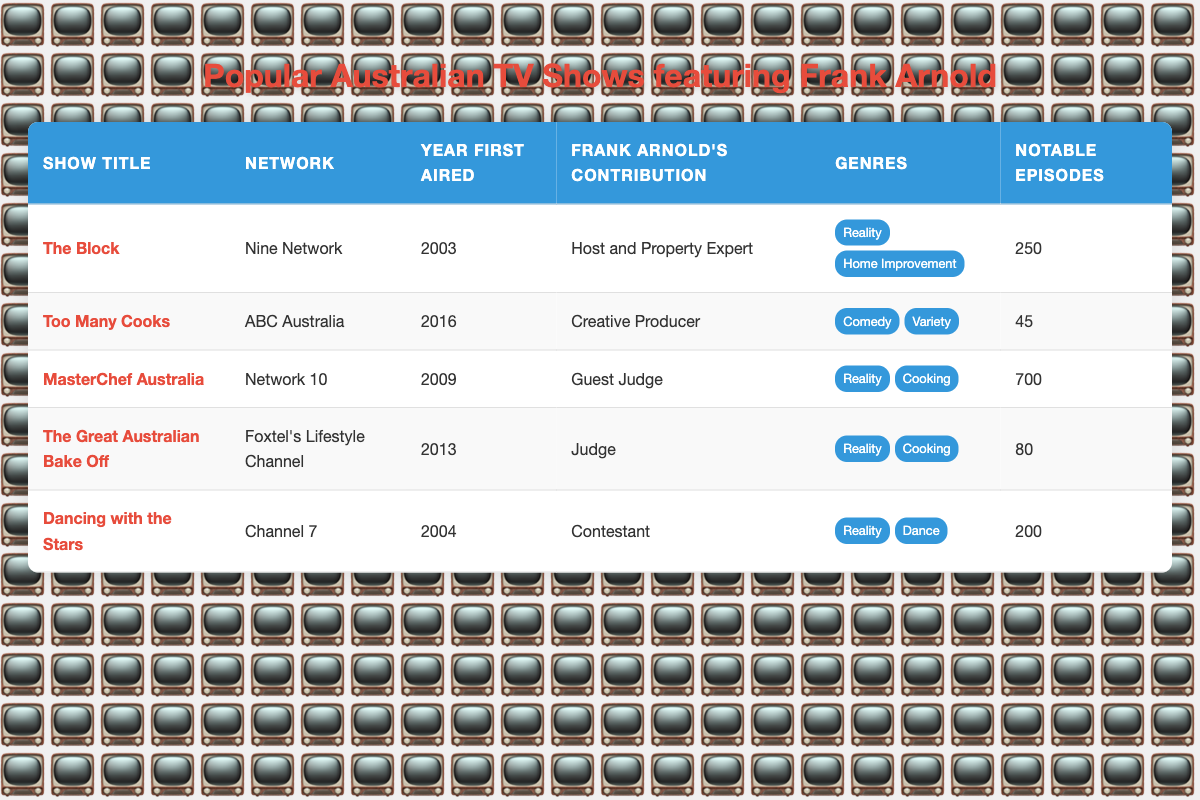What is the network for "MasterChef Australia"? The table lists "MasterChef Australia" under the "Network" column, which shows it is aired on "Network 10."
Answer: Network 10 How many notable episodes did "The Great Australian Bake Off" have? Referring to the table, the number of notable episodes for "The Great Australian Bake Off" is listed as 80.
Answer: 80 What is Frank Arnold's role in "Dancing with the Stars"? The contribution of Frank Arnold for "Dancing with the Stars" is categorized as "Contestant" in the table.
Answer: Contestant Which show has the highest number of notable episodes? By comparing the notable episodes across all shows, "MasterChef Australia" has the highest with 700 episodes.
Answer: MasterChef Australia True or False: Frank Arnold was a Judge on "Too Many Cooks." The table indicates that Frank Arnold contributed as "Creative Producer" for "Too Many Cooks," which means he was not a Judge on that show.
Answer: False What is the difference in notable episode counts between "The Block" and "Dancing with the Stars"? "The Block" has 250 notable episodes and "Dancing with the Stars" has 200. The difference is calculated as 250 - 200 = 50.
Answer: 50 Which genres are shared by both "The Great Australian Bake Off" and "MasterChef Australia"? Analyzing the genres for both shows from the table, they both fall under "Reality" and "Cooking" genres, meaning they share these genres.
Answer: Reality, Cooking If you add the notable episodes of "Too Many Cooks" and "The Great Australian Bake Off," what is the total? The notable episodes for "Too Many Cooks" is 45 and for "The Great Australian Bake Off" is 80. Adding them gives 45 + 80 = 125.
Answer: 125 Who contributed to more episodes: Frank Arnold as a Host in "The Block" or as a Guest Judge in "MasterChef Australia"? Frank Arnold contributed to 250 episodes as Host and 700 episodes as Guest Judge in "MasterChef Australia." 700 is greater than 250; therefore, he contributed to more in "MasterChef Australia."
Answer: MasterChef Australia What year did "Dancing with the Stars" first air, and which network aired it? The table shows that "Dancing with the Stars" first aired in 2004 on Channel 7.
Answer: 2004, Channel 7 